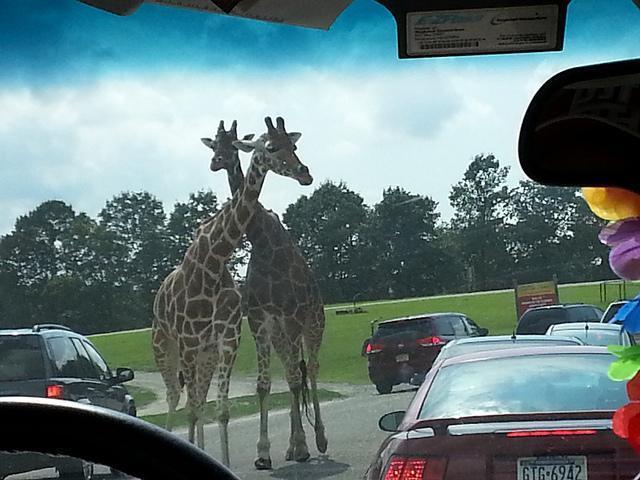How many giraffes are there?
Give a very brief answer. 2. How many cars are visible?
Give a very brief answer. 4. How many men are drinking milk?
Give a very brief answer. 0. 